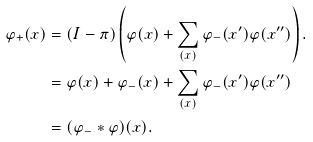Convert formula to latex. <formula><loc_0><loc_0><loc_500><loc_500>\varphi _ { + } ( x ) & = ( I - \pi ) \left ( \varphi ( x ) + \sum _ { ( x ) } \varphi _ { - } ( x ^ { \prime } ) \varphi ( x ^ { \prime \prime } ) \right ) . \\ & = \varphi ( x ) + \varphi _ { - } ( x ) + \sum _ { ( x ) } \varphi _ { - } ( x ^ { \prime } ) \varphi ( x ^ { \prime \prime } ) \\ & = ( \varphi _ { - } * \varphi ) ( x ) .</formula> 